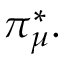<formula> <loc_0><loc_0><loc_500><loc_500>\pi _ { \mu } ^ { * } .</formula> 